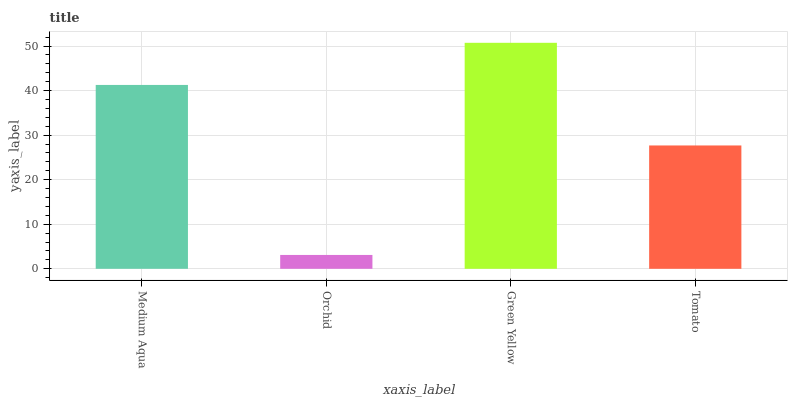Is Orchid the minimum?
Answer yes or no. Yes. Is Green Yellow the maximum?
Answer yes or no. Yes. Is Green Yellow the minimum?
Answer yes or no. No. Is Orchid the maximum?
Answer yes or no. No. Is Green Yellow greater than Orchid?
Answer yes or no. Yes. Is Orchid less than Green Yellow?
Answer yes or no. Yes. Is Orchid greater than Green Yellow?
Answer yes or no. No. Is Green Yellow less than Orchid?
Answer yes or no. No. Is Medium Aqua the high median?
Answer yes or no. Yes. Is Tomato the low median?
Answer yes or no. Yes. Is Orchid the high median?
Answer yes or no. No. Is Orchid the low median?
Answer yes or no. No. 